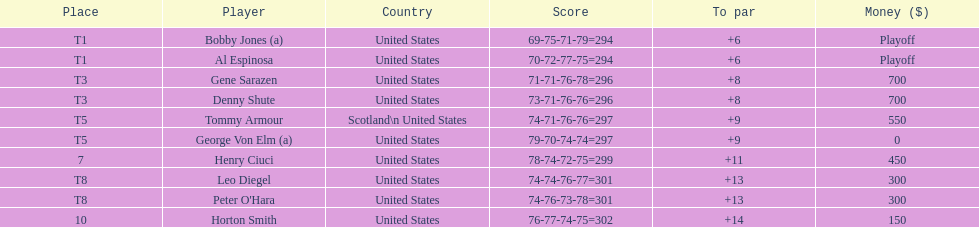Which two players tied for first place? Bobby Jones (a), Al Espinosa. 